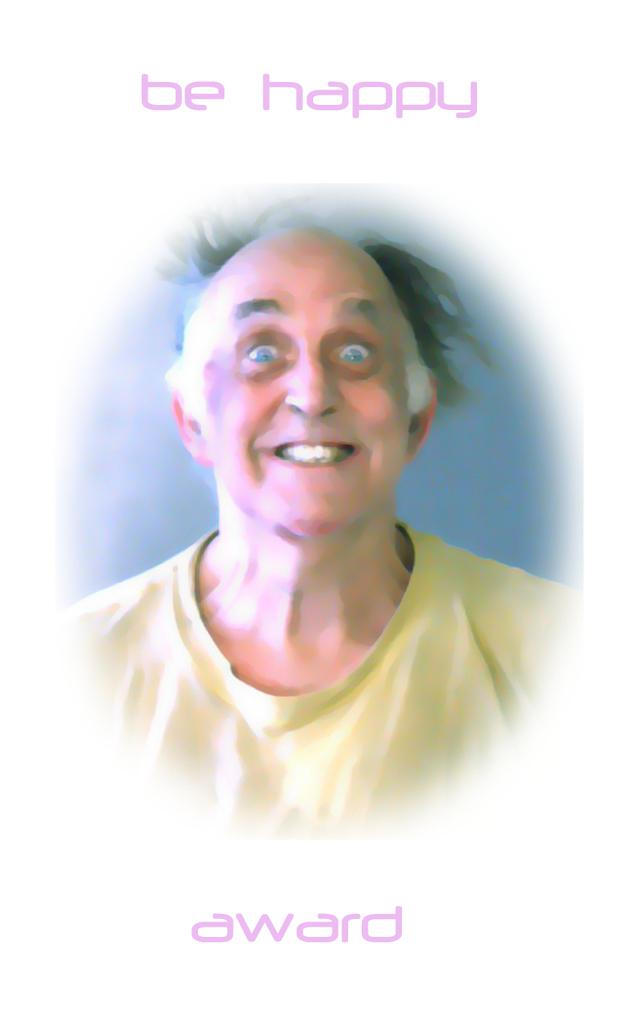What is the main subject of the image? The image might be a painting of a person. Can you describe any text that is visible in the image? Yes, there is text visible at the top and bottom of the image. What type of brass pin is attached to the person's clothing in the image? There is no brass pin or any other type of pin visible in the image. 